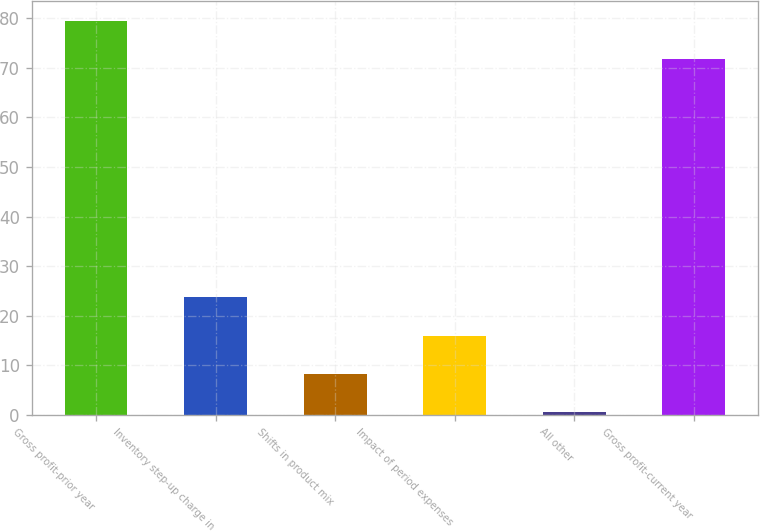Convert chart. <chart><loc_0><loc_0><loc_500><loc_500><bar_chart><fcel>Gross profit-prior year<fcel>Inventory step-up charge in<fcel>Shifts in product mix<fcel>Impact of period expenses<fcel>All other<fcel>Gross profit-current year<nl><fcel>79.54<fcel>23.72<fcel>8.24<fcel>15.98<fcel>0.5<fcel>71.8<nl></chart> 